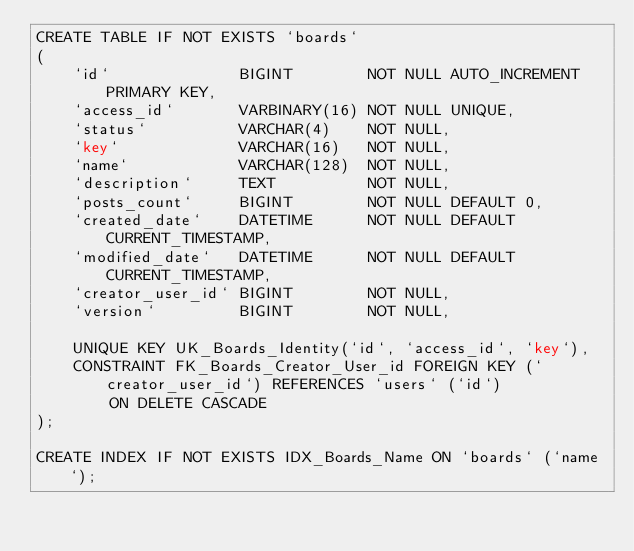<code> <loc_0><loc_0><loc_500><loc_500><_SQL_>CREATE TABLE IF NOT EXISTS `boards`
(
    `id`              BIGINT        NOT NULL AUTO_INCREMENT PRIMARY KEY,
    `access_id`       VARBINARY(16) NOT NULL UNIQUE,
    `status`          VARCHAR(4)    NOT NULL,
    `key`             VARCHAR(16)   NOT NULL,
    `name`            VARCHAR(128)  NOT NULL,
    `description`     TEXT          NOT NULL,
    `posts_count`     BIGINT        NOT NULL DEFAULT 0,
    `created_date`    DATETIME      NOT NULL DEFAULT CURRENT_TIMESTAMP,
    `modified_date`   DATETIME      NOT NULL DEFAULT CURRENT_TIMESTAMP,
    `creator_user_id` BIGINT        NOT NULL,
    `version`         BIGINT        NOT NULL,

    UNIQUE KEY UK_Boards_Identity(`id`, `access_id`, `key`),
    CONSTRAINT FK_Boards_Creator_User_id FOREIGN KEY (`creator_user_id`) REFERENCES `users` (`id`)
        ON DELETE CASCADE
);

CREATE INDEX IF NOT EXISTS IDX_Boards_Name ON `boards` (`name`);
</code> 